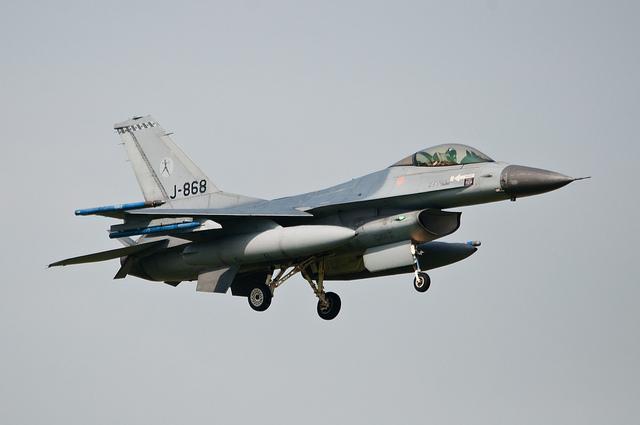How many people are in the plane?
Give a very brief answer. 1. 